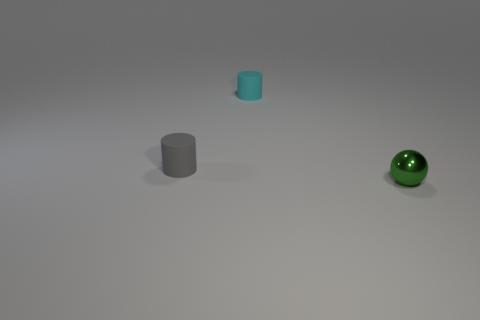Is there anything else that has the same shape as the tiny green shiny object?
Keep it short and to the point. No. Is there anything else that is the same color as the metallic sphere?
Keep it short and to the point. No. Does the small thing behind the gray thing have the same color as the tiny object in front of the gray matte thing?
Ensure brevity in your answer.  No. There is a tiny matte cylinder behind the tiny gray matte cylinder; are there any small cyan rubber things left of it?
Provide a short and direct response. No. Are there fewer gray matte cylinders on the right side of the small ball than cyan things that are left of the small gray cylinder?
Your response must be concise. No. Does the small cylinder that is behind the gray matte cylinder have the same material as the small object to the left of the tiny cyan thing?
Your answer should be very brief. Yes. What number of big things are either green things or yellow cylinders?
Offer a very short reply. 0. There is a cyan thing that is the same material as the gray thing; what shape is it?
Your answer should be compact. Cylinder. Are there fewer tiny matte things that are in front of the tiny green metal object than brown cylinders?
Ensure brevity in your answer.  No. Does the tiny gray thing have the same shape as the green object?
Provide a succinct answer. No. 